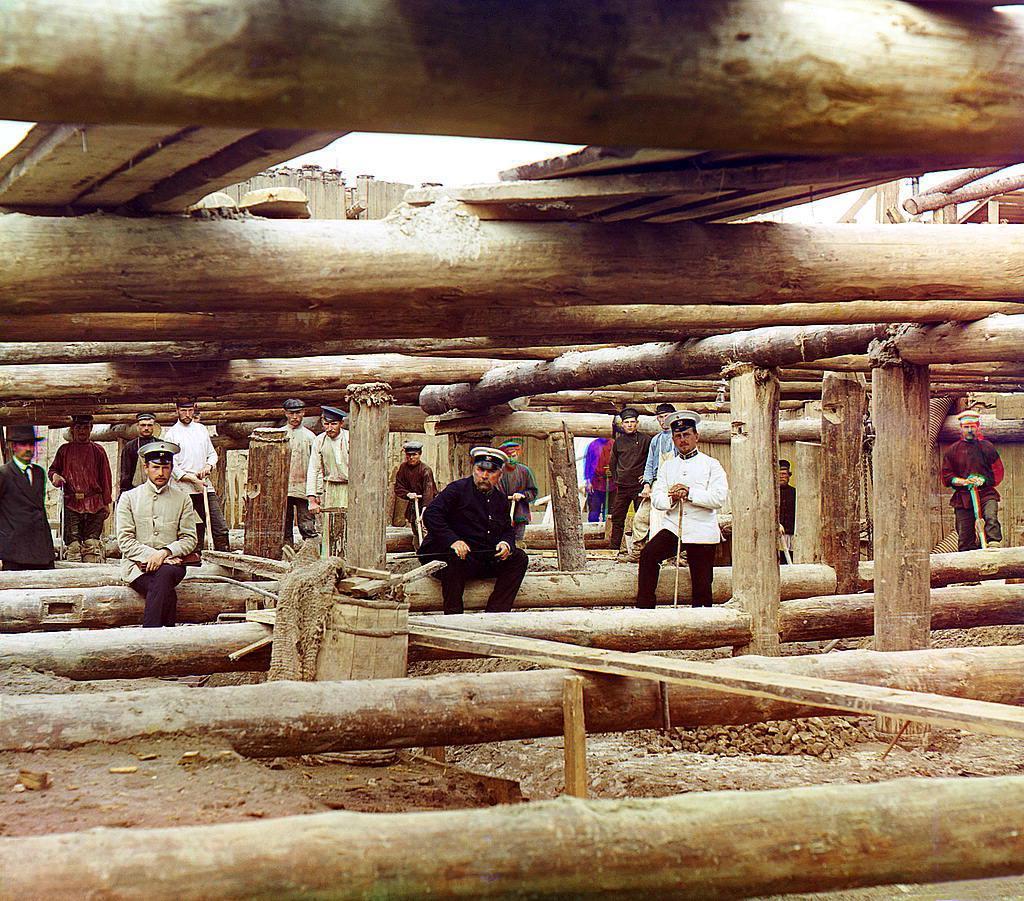Describe this image in one or two sentences. In the foreground of this image, there are few persons sitting on the wooden trunk and in the background, there are few persons standing. We can also many wooden trunks all over the image and it seems like a construction. 